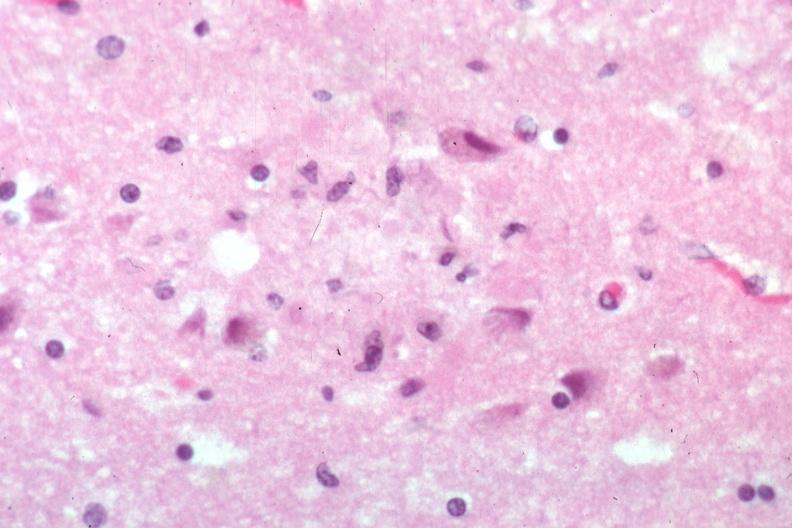what is present?
Answer the question using a single word or phrase. Senile plaque 